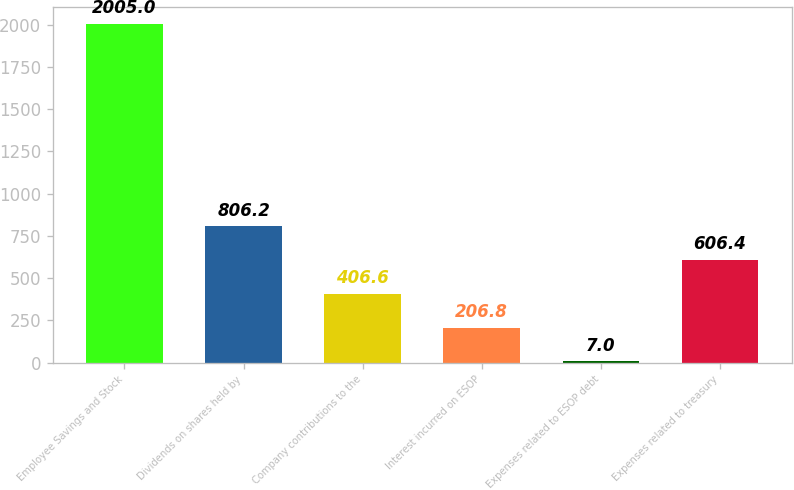Convert chart. <chart><loc_0><loc_0><loc_500><loc_500><bar_chart><fcel>Employee Savings and Stock<fcel>Dividends on shares held by<fcel>Company contributions to the<fcel>Interest incurred on ESOP<fcel>Expenses related to ESOP debt<fcel>Expenses related to treasury<nl><fcel>2005<fcel>806.2<fcel>406.6<fcel>206.8<fcel>7<fcel>606.4<nl></chart> 